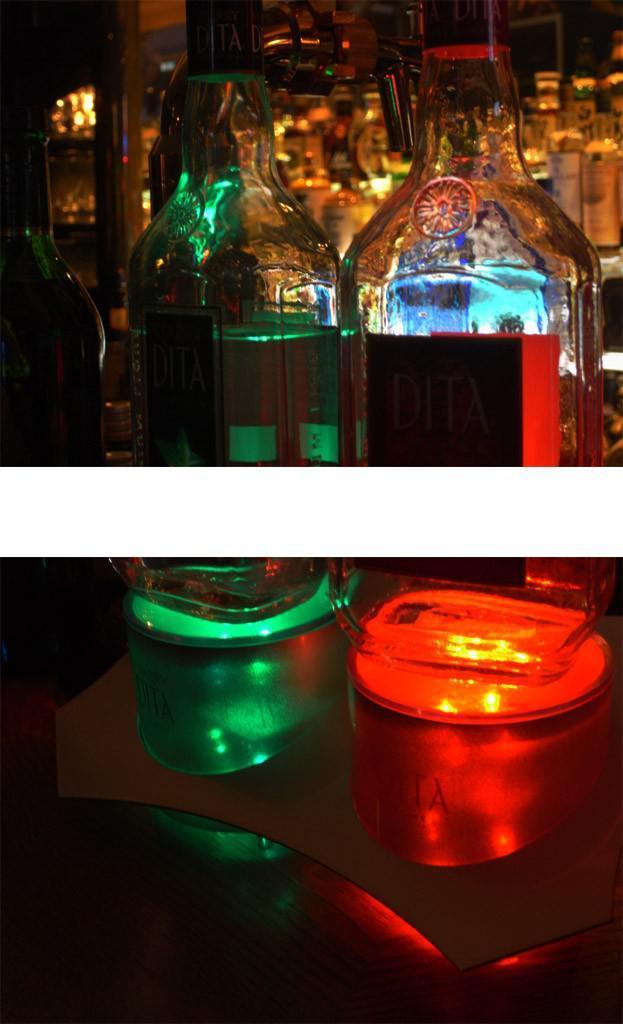How would you summarize this image in a sentence or two? The picture is divided into two photo graphs where the above one has glass bottles and the picture is clicked inside a restaurant and in the below picture there are two glass vases of green and red color. 